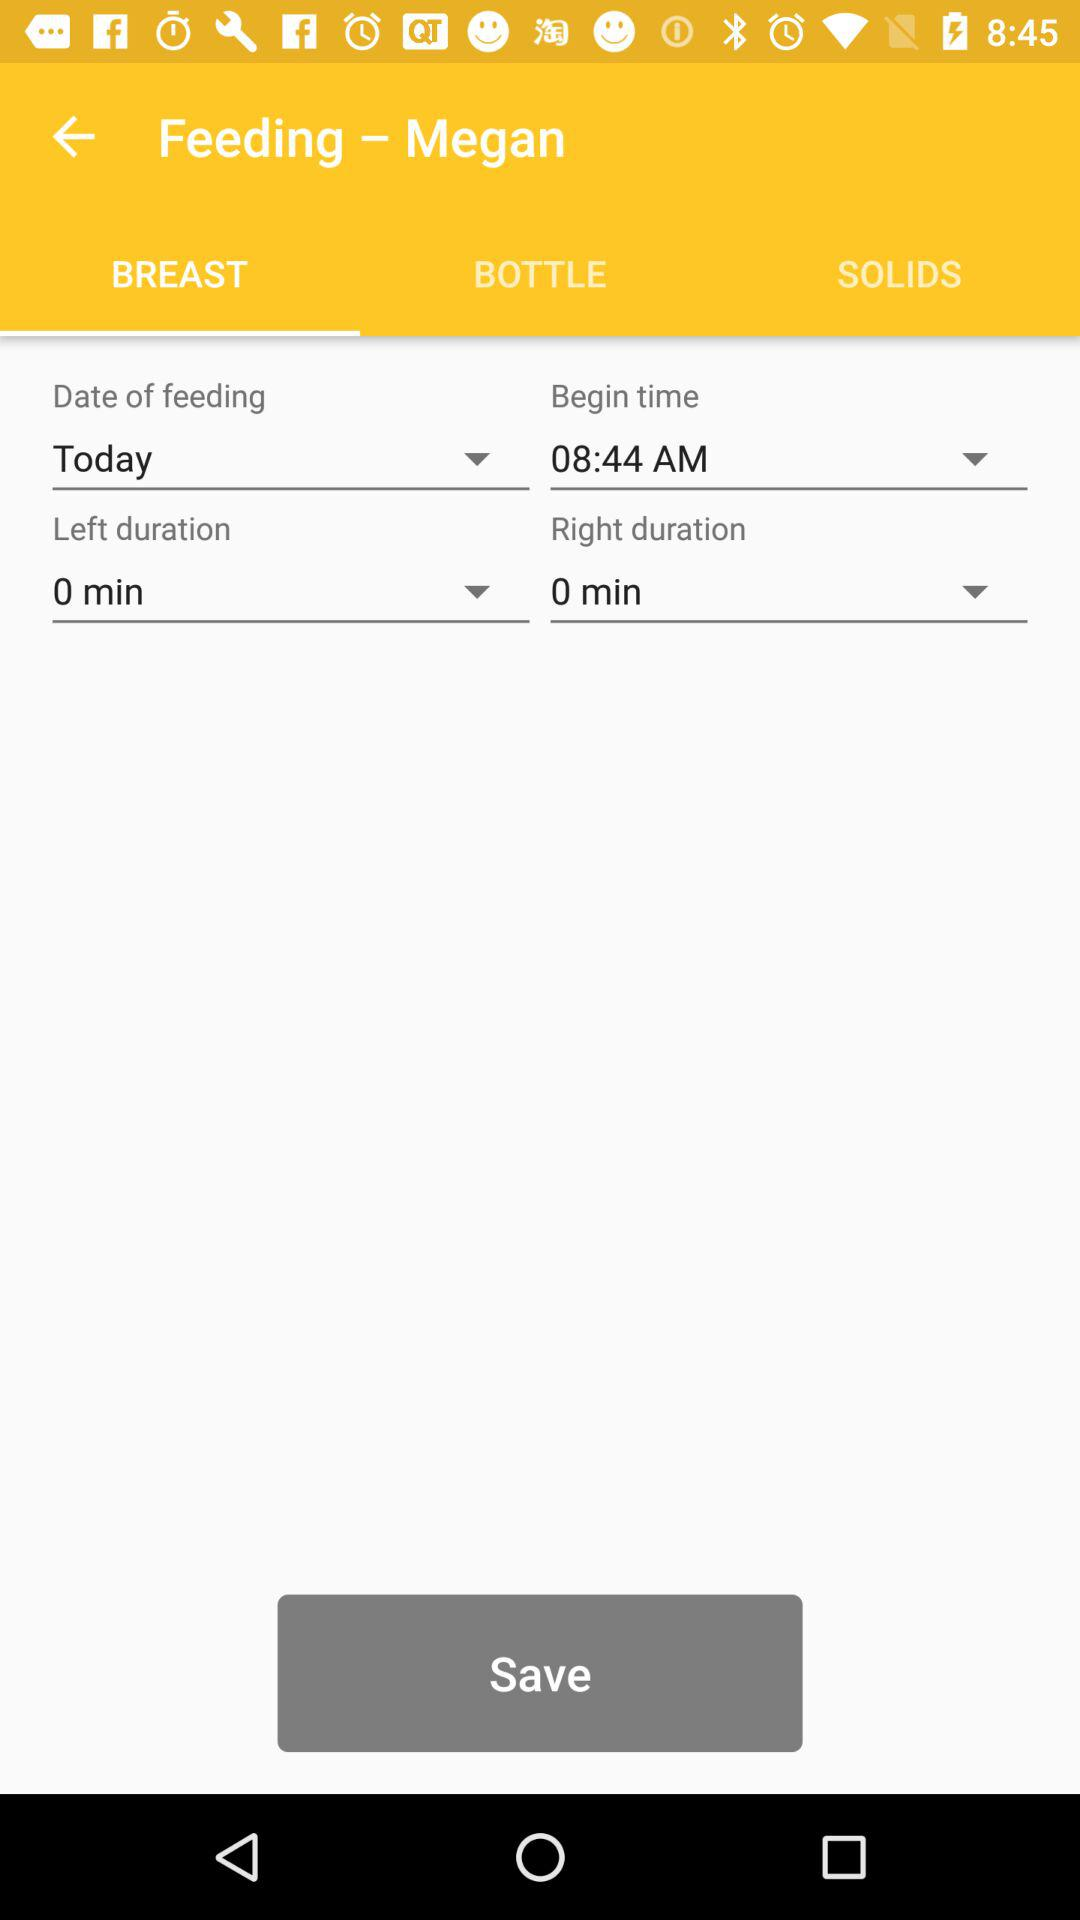Which tab is selected? The selected tab is "BREAST". 